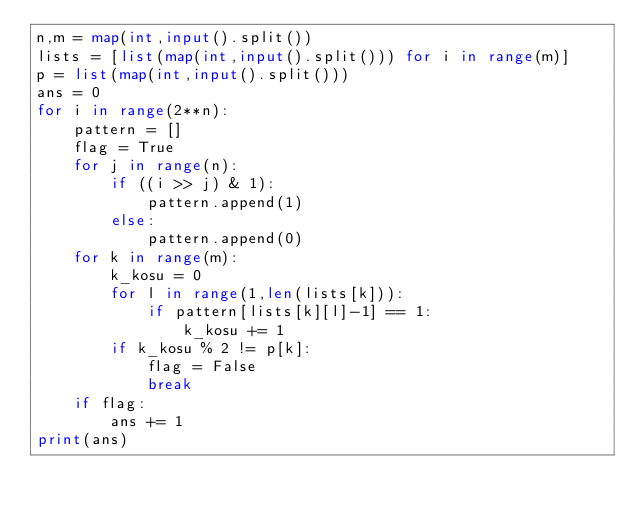Convert code to text. <code><loc_0><loc_0><loc_500><loc_500><_Python_>n,m = map(int,input().split())
lists = [list(map(int,input().split())) for i in range(m)]
p = list(map(int,input().split()))
ans = 0
for i in range(2**n):
    pattern = []
    flag = True
    for j in range(n):
        if ((i >> j) & 1):
            pattern.append(1)
        else:
            pattern.append(0)
    for k in range(m):
        k_kosu = 0
        for l in range(1,len(lists[k])):
            if pattern[lists[k][l]-1] == 1:
                k_kosu += 1
        if k_kosu % 2 != p[k]:
            flag = False
            break
    if flag:
        ans += 1 
print(ans)</code> 